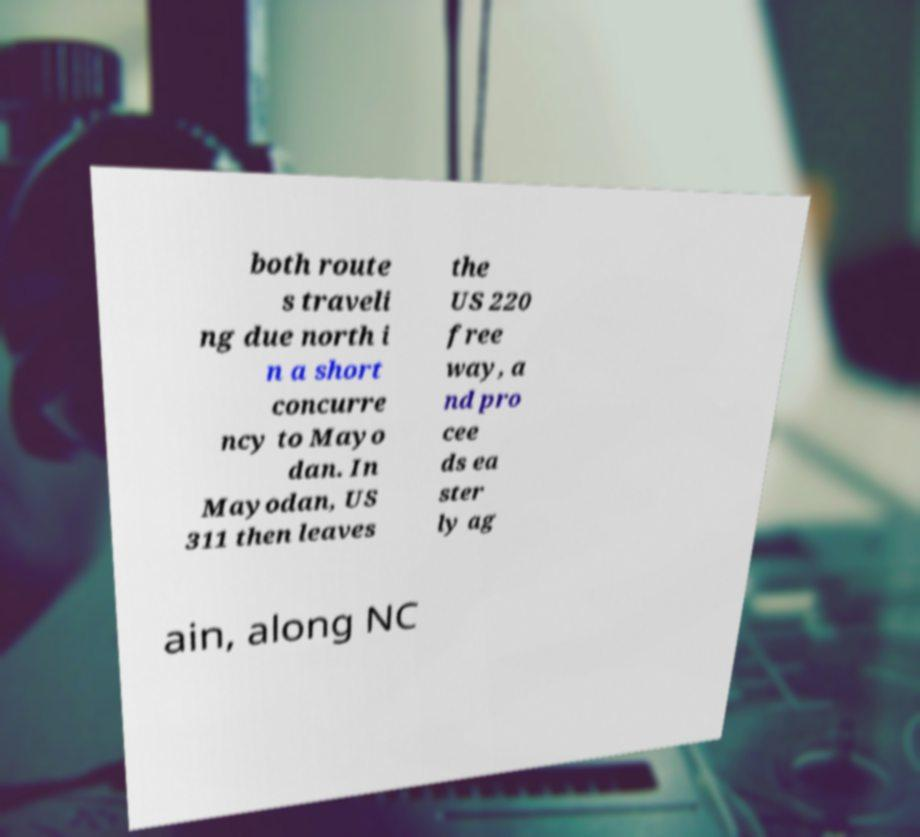I need the written content from this picture converted into text. Can you do that? both route s traveli ng due north i n a short concurre ncy to Mayo dan. In Mayodan, US 311 then leaves the US 220 free way, a nd pro cee ds ea ster ly ag ain, along NC 